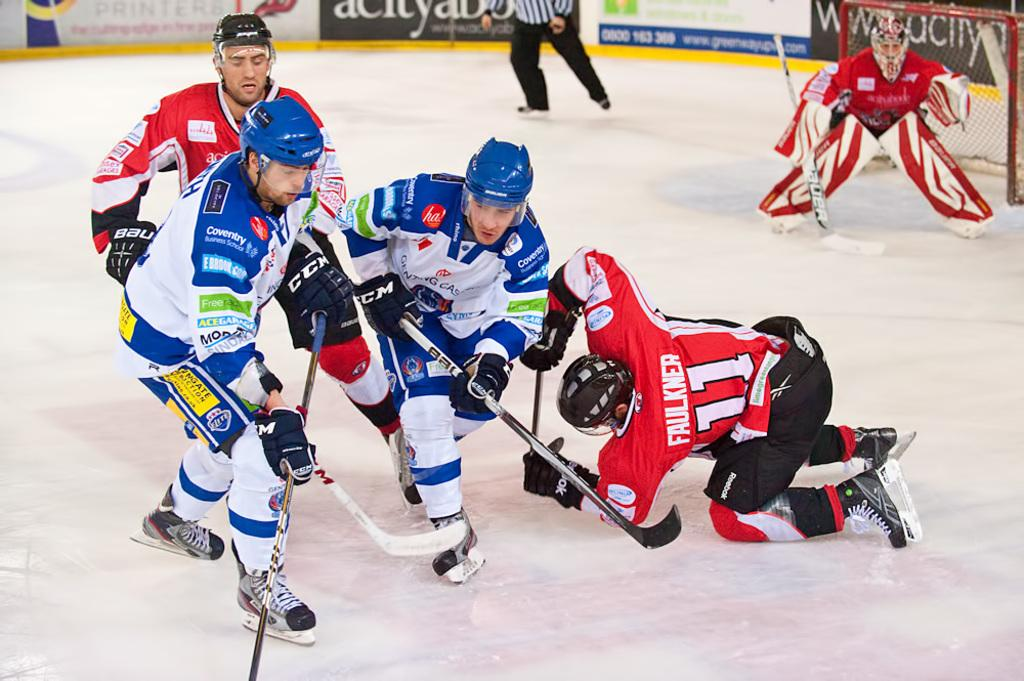<image>
Provide a brief description of the given image. Faulkner is the hockey player who is falling down during the skirmish. 